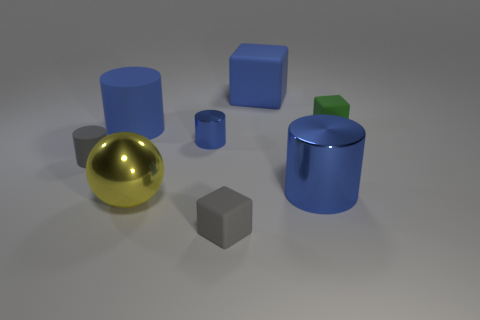Subtract all blue cylinders. How many were subtracted if there are1blue cylinders left? 2 Subtract all red balls. How many blue cylinders are left? 3 Subtract all gray cylinders. How many cylinders are left? 3 Subtract all large shiny cylinders. How many cylinders are left? 3 Add 2 big yellow things. How many objects exist? 10 Subtract all cyan cylinders. Subtract all cyan balls. How many cylinders are left? 4 Subtract all balls. How many objects are left? 7 Add 7 yellow shiny objects. How many yellow shiny objects are left? 8 Add 2 green matte objects. How many green matte objects exist? 3 Subtract 3 blue cylinders. How many objects are left? 5 